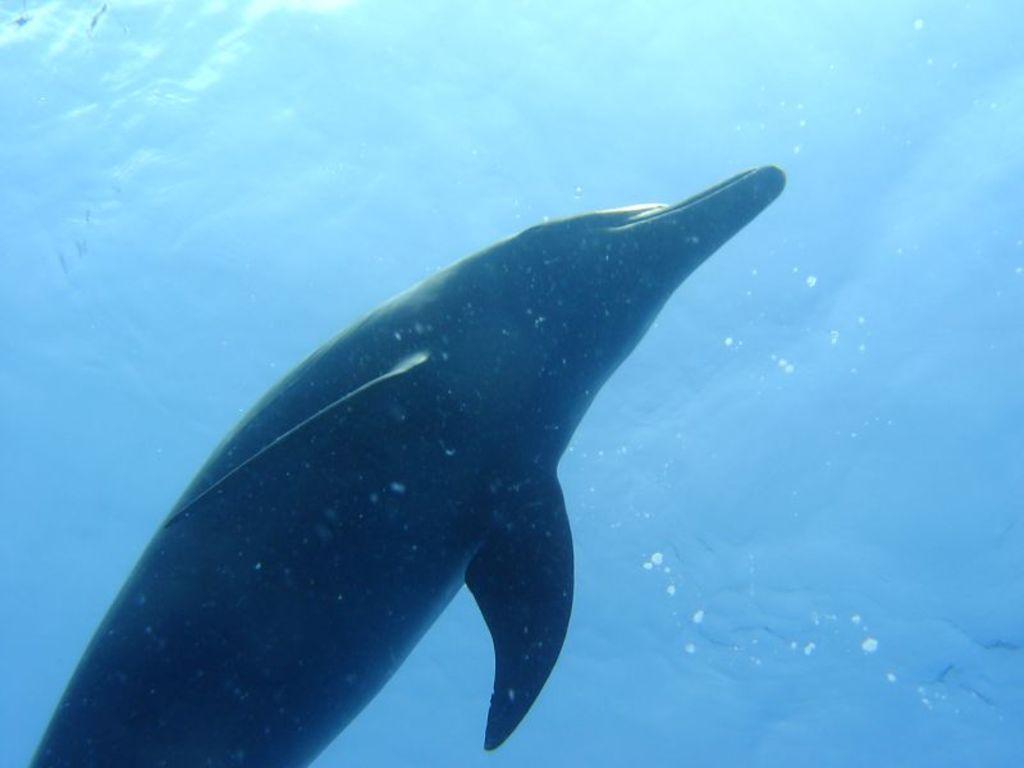How would you summarize this image in a sentence or two? In this image there is a dolphin in the water. 